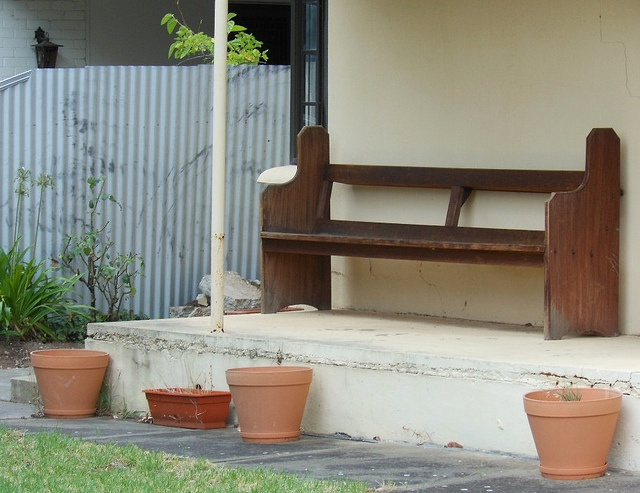Describe the objects in this image and their specific colors. I can see bench in gray, maroon, black, and darkgray tones, potted plant in gray, salmon, and tan tones, potted plant in gray, salmon, tan, and brown tones, potted plant in gray, brown, and tan tones, and potted plant in gray, maroon, and brown tones in this image. 